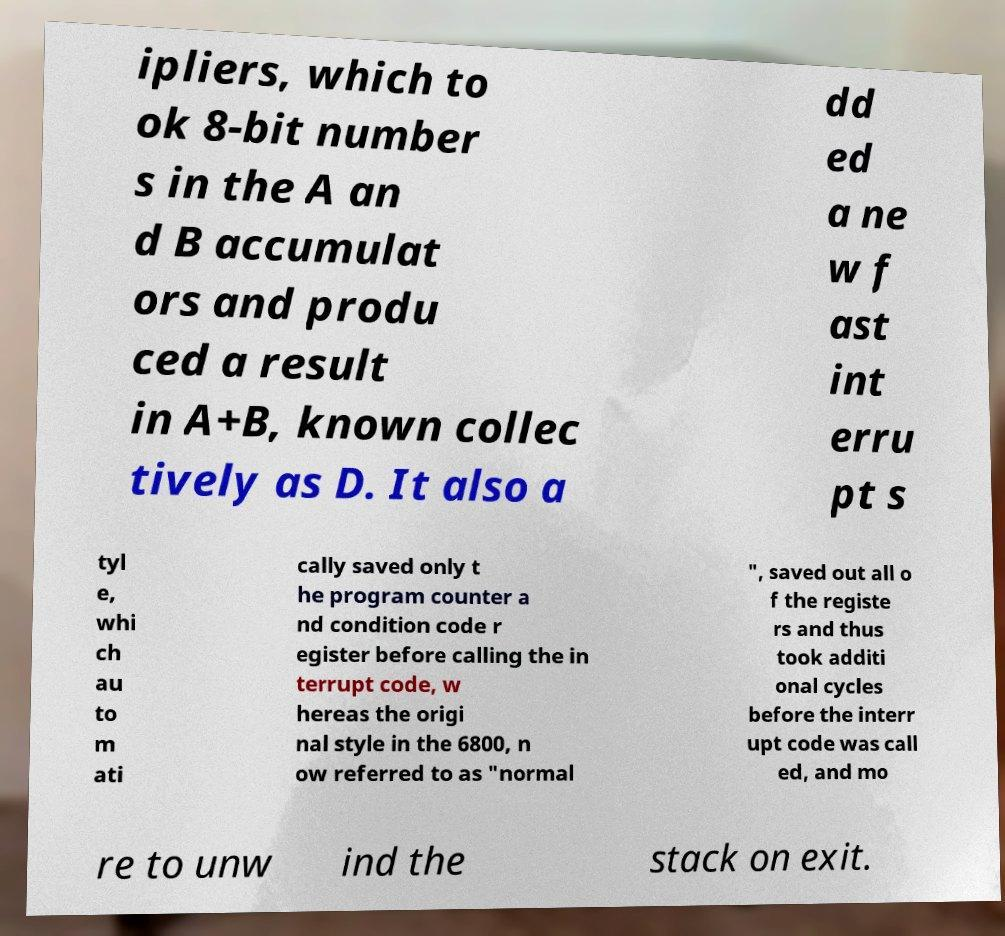Please read and relay the text visible in this image. What does it say? ipliers, which to ok 8-bit number s in the A an d B accumulat ors and produ ced a result in A+B, known collec tively as D. It also a dd ed a ne w f ast int erru pt s tyl e, whi ch au to m ati cally saved only t he program counter a nd condition code r egister before calling the in terrupt code, w hereas the origi nal style in the 6800, n ow referred to as "normal ", saved out all o f the registe rs and thus took additi onal cycles before the interr upt code was call ed, and mo re to unw ind the stack on exit. 